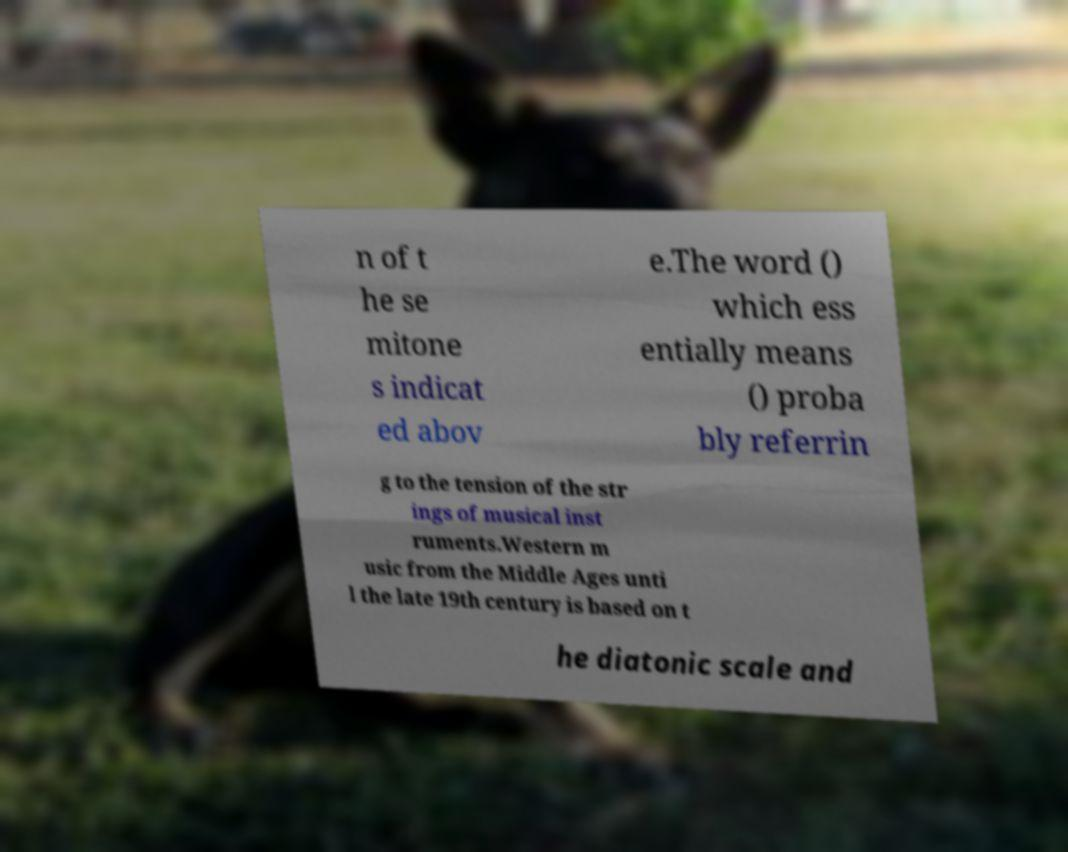Could you extract and type out the text from this image? n of t he se mitone s indicat ed abov e.The word () which ess entially means () proba bly referrin g to the tension of the str ings of musical inst ruments.Western m usic from the Middle Ages unti l the late 19th century is based on t he diatonic scale and 